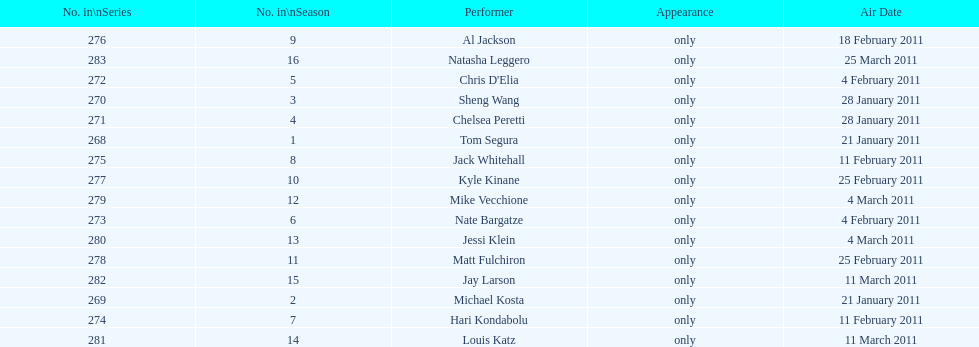Who made their initial appearance first, tom segura or jay larson? Tom Segura. 